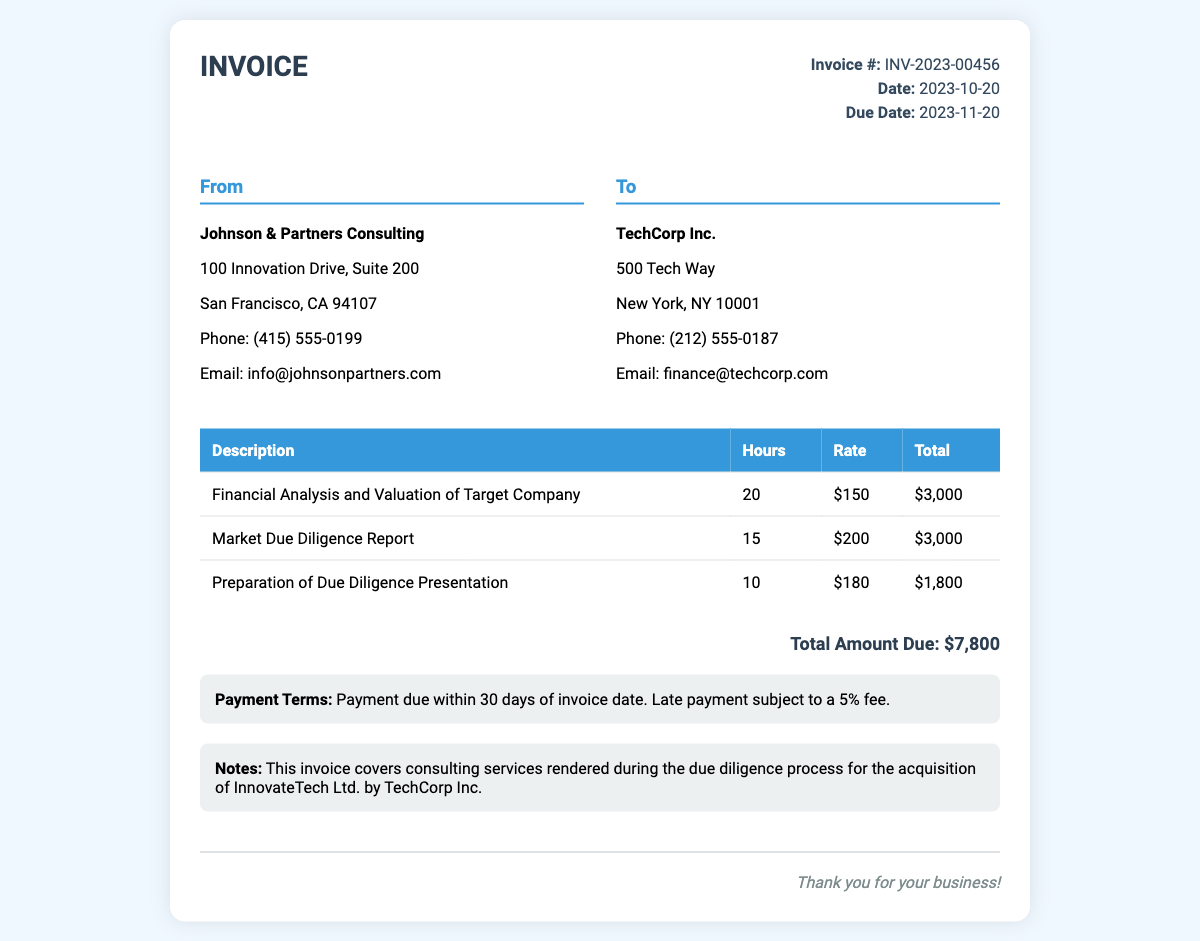What is the invoice number? The invoice number is stated at the top of the document as Invoice #: INV-2023-00456.
Answer: INV-2023-00456 What is the total amount due? The total amount due is detailed at the bottom of the invoice in the total amount section.
Answer: $7,800 Who is the consultant firm? The name of the consulting firm is listed in the "From" section of the document.
Answer: Johnson & Partners Consulting What is the due date for the invoice? The due date is provided in the invoice details section as Due Date: 2023-11-20.
Answer: 2023-11-20 How many hours were billed for the Financial Analysis service? The hours billed for the Financial Analysis and Valuation of Target Company service are specified in the services table.
Answer: 20 What are the payment terms stated in the invoice? The payment terms are outlined in a specific section addressing when payment is due and conditions for late payment.
Answer: Payment due within 30 days of invoice date. Late payment subject to a 5% fee How many services are listed in the invoice? The total services listed can be counted in the services table under the description column.
Answer: 3 What is the rate for the Market Due Diligence Report? The rate for this service is provided in the services table next to the corresponding service description.
Answer: $200 Which client is receiving the invoice? The client receiving the invoice is identified in the "To" section at the top of the document.
Answer: TechCorp Inc 